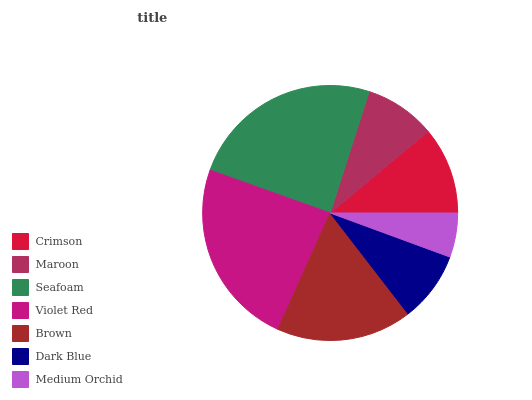Is Medium Orchid the minimum?
Answer yes or no. Yes. Is Seafoam the maximum?
Answer yes or no. Yes. Is Maroon the minimum?
Answer yes or no. No. Is Maroon the maximum?
Answer yes or no. No. Is Crimson greater than Maroon?
Answer yes or no. Yes. Is Maroon less than Crimson?
Answer yes or no. Yes. Is Maroon greater than Crimson?
Answer yes or no. No. Is Crimson less than Maroon?
Answer yes or no. No. Is Crimson the high median?
Answer yes or no. Yes. Is Crimson the low median?
Answer yes or no. Yes. Is Maroon the high median?
Answer yes or no. No. Is Maroon the low median?
Answer yes or no. No. 